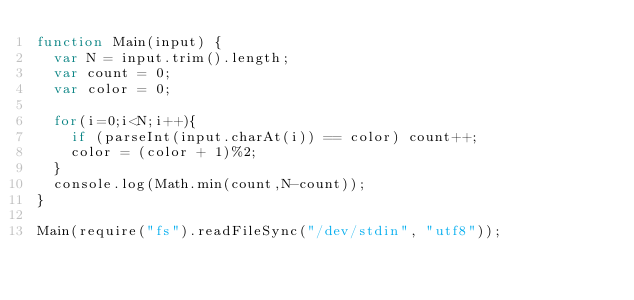Convert code to text. <code><loc_0><loc_0><loc_500><loc_500><_JavaScript_>function Main(input) {
  var N = input.trim().length;
  var count = 0;
  var color = 0;
  
  for(i=0;i<N;i++){
    if (parseInt(input.charAt(i)) == color) count++;
    color = (color + 1)%2;
  }
  console.log(Math.min(count,N-count));
}
 
Main(require("fs").readFileSync("/dev/stdin", "utf8"));</code> 